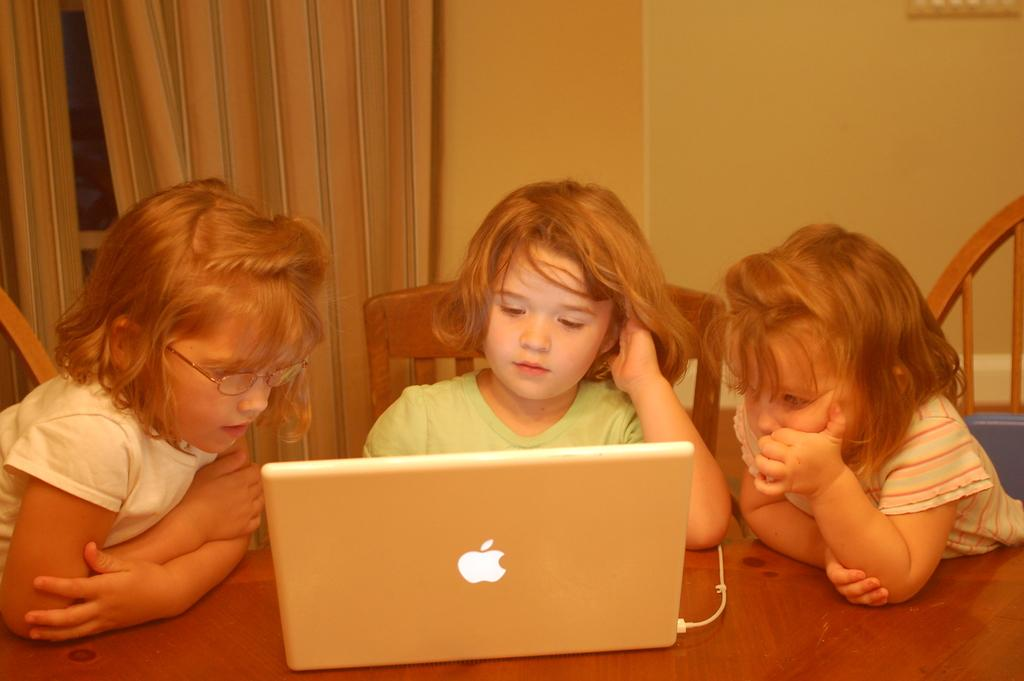How many children are present in the image? There are three children in the image. What are the children doing in the image? The children are sitting on chairs. What object is on the table in front of the children? There is a laptop on a table in front of the children. What can be seen in the background of the image? There is a wall and a curtain in the background of the image. What type of goat can be seen cooking in the image? There is no goat or cooking activity present in the image. Can you tell me where the nearest shop is located in the image? There is no shop visible in the image; it only features three children, chairs, a laptop, and a background with a wall and curtain. 